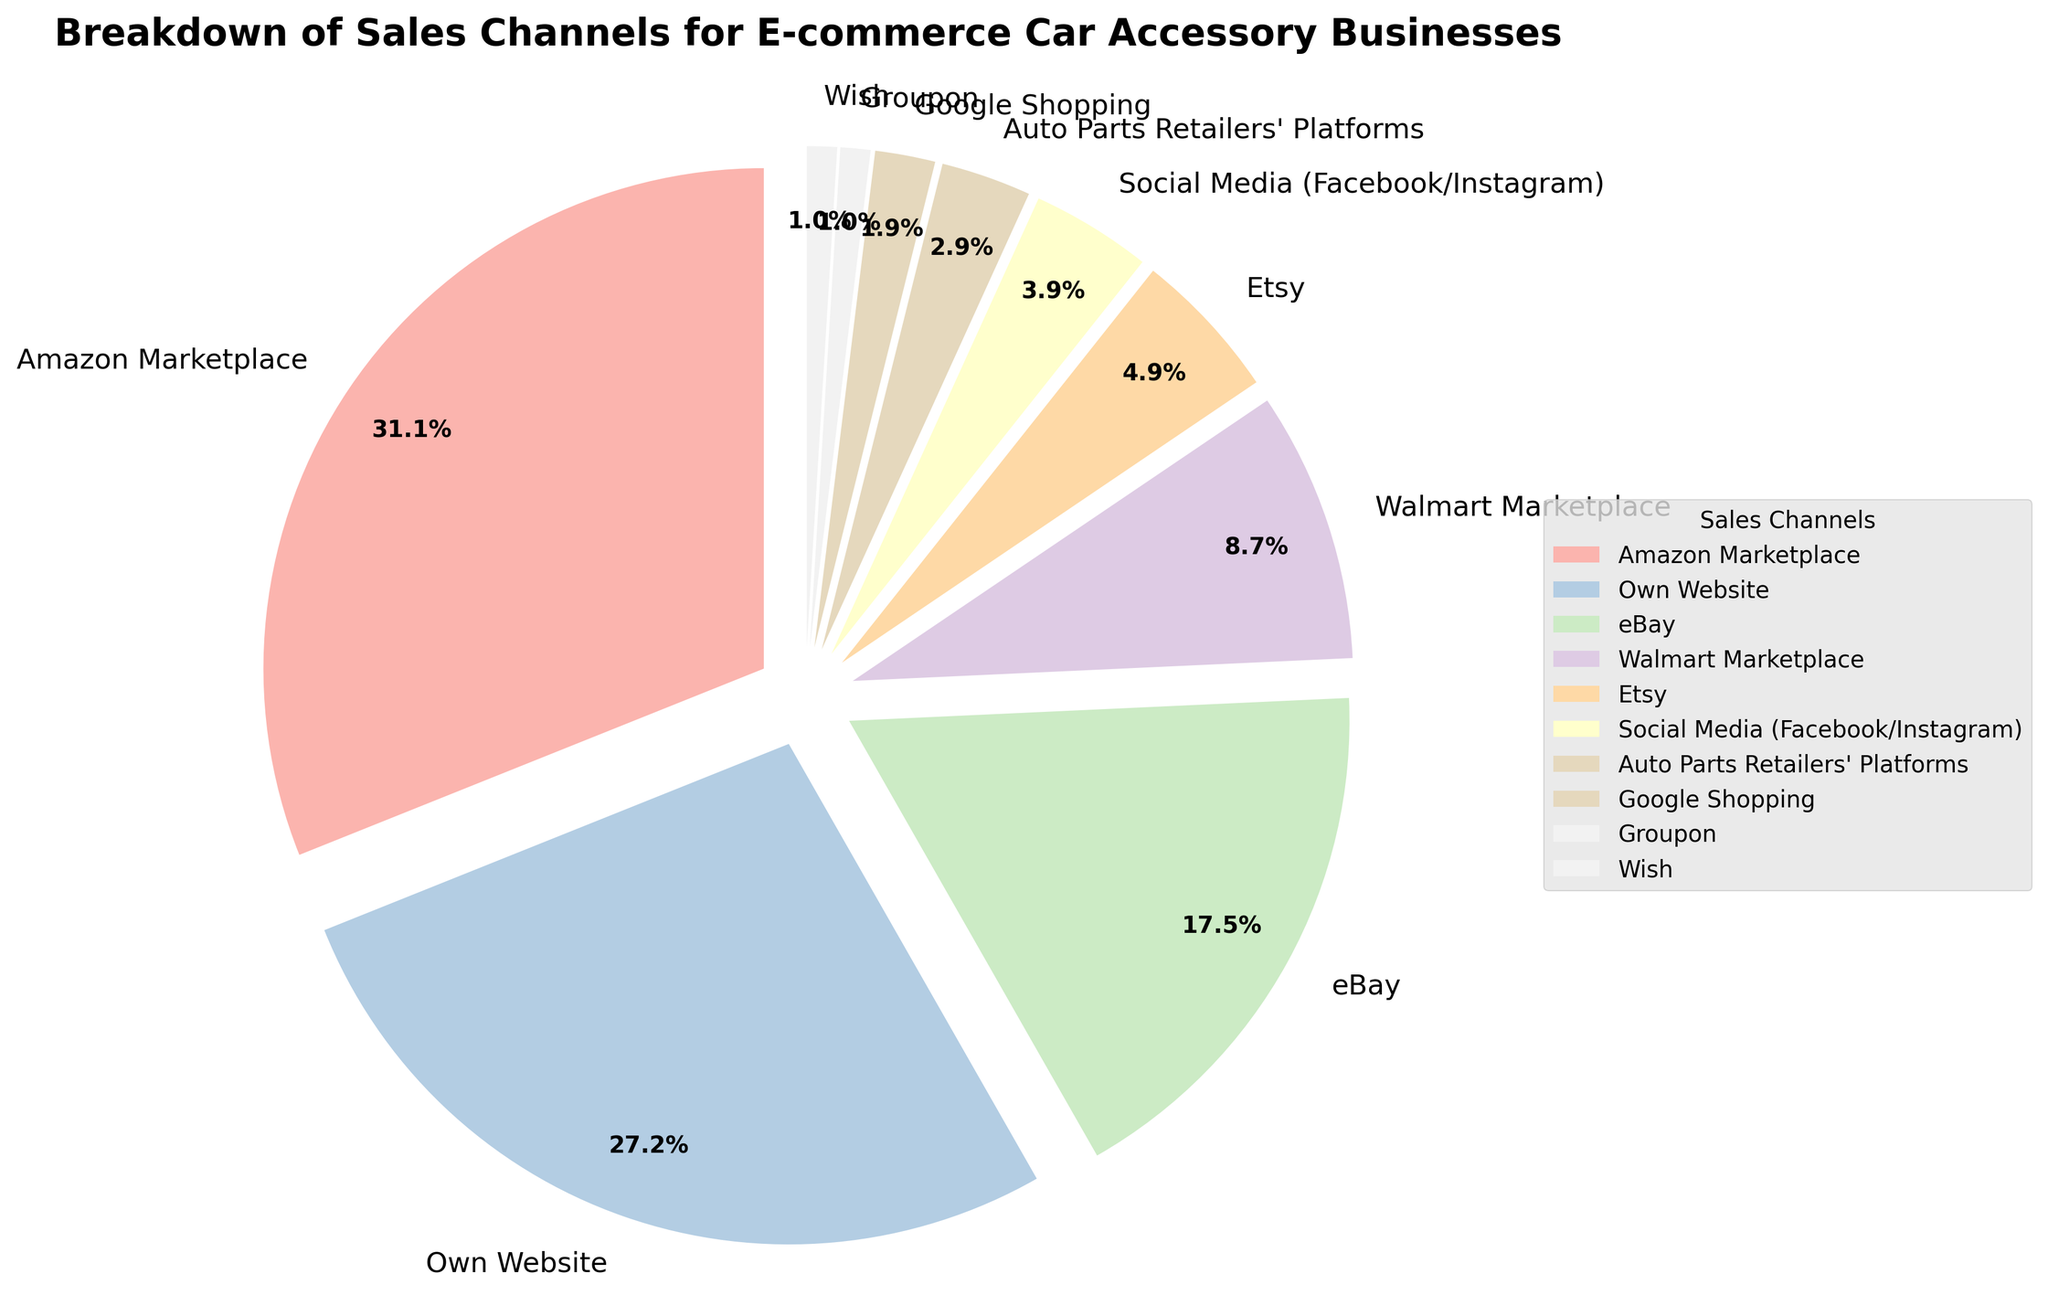Which sales channel has the highest percentage of sales? By looking at the pie chart, the segment with the largest area represents the sales channel with the highest percentage. Amazon Marketplace is the largest segment.
Answer: Amazon Marketplace Which three sales channels have the smallest percentage of sales? By comparing all segments visually, the three smallest segments belong to Auto Parts Retailers' Platforms, Google Shopping, Groupon, and Wish. Wish and Groupon have the same small size, so they are both included.
Answer: Auto Parts Retailers' Platforms, Google Shopping, Groupon, Wish What is the combined percentage of sales from Amazon Marketplace and Own Website? The percentage of Amazon Marketplace sales is 32%, and the percentage of Own Website sales is 28%. Adding these together gives 32 + 28 = 60%.
Answer: 60% How much larger is the percentage of sales from Amazon Marketplace compared to that from eBay? The percentage of Amazon Marketplace sales is 32%, and that from eBay is 18%. The difference is 32 - 18 = 14%.
Answer: 14% Which sales channel's segment in the pie chart is colored blue and what is its percentage? The color blue represents the segment for Walmart Marketplace. By the legend next to the pie chart, we see that Walmart Marketplace's percentage is 9%.
Answer: Walmart Marketplace, 9% Which sales channel has a percentage roughly half that of the Own Website channel? By inspecting the chart, the Own Website channel has 28%, and roughly half of it is approx 14%. eBay's percentage is 18%, which is close to half of Own Website's percentage.
Answer: eBay What is the average percentage of all sales channels except Amazon Marketplace and Own Website? Total percentage is 100%, subtracting Amazon Marketplace (32%) and Own Website (28%) leaves 40%. There are 8 other channels. 40% divided by 8 is 5%.
Answer: 5% Which segment representing Social Media (Facebook/Instagram) is colored and what percentage does it represent? By looking at the legend, Social Media (Facebook/Instagram) is represented by the fifth segment, which matches the color pink. It's percentage is 4%.
Answer: Social Media (Facebook/Instagram), 4% How does the percentage of sales from Etsy compare to that from Auto Parts Retailers' Platforms and Social Media (Facebook/Instagram) combined? Etsy has 5%, Auto Parts Retailers' Platforms have 3%, and Social Media (Facebook/Instagram) has 4%. Combining Auto Parts Retailers' Platforms and Social Media (Facebook/Instagram) gives 3 + 4 = 7%, which is larger than Etsy's 5%.
Answer: Less What percentage of the total sales is contributed by sales channels other than the top three? The top three channels are Amazon Marketplace (32%), Own Website (28%), and eBay (18%), summing to 78%. The remaining percentage is 100% - 78% = 22%.
Answer: 22% 